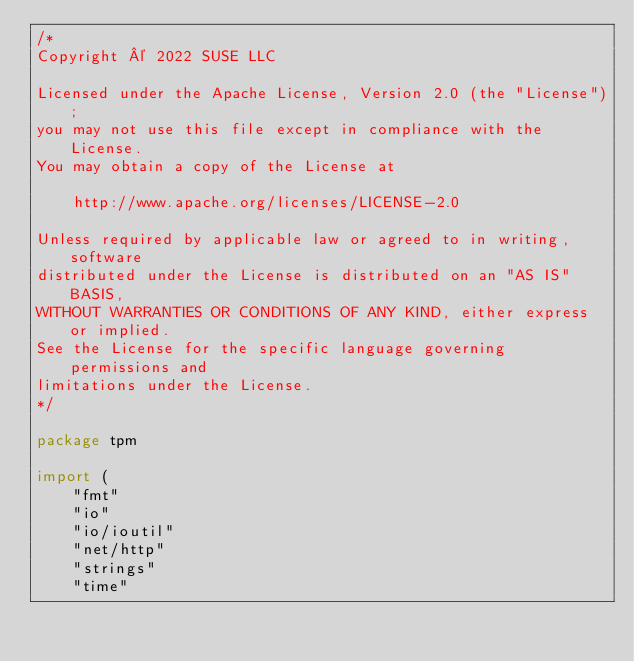<code> <loc_0><loc_0><loc_500><loc_500><_Go_>/*
Copyright © 2022 SUSE LLC

Licensed under the Apache License, Version 2.0 (the "License");
you may not use this file except in compliance with the License.
You may obtain a copy of the License at

    http://www.apache.org/licenses/LICENSE-2.0

Unless required by applicable law or agreed to in writing, software
distributed under the License is distributed on an "AS IS" BASIS,
WITHOUT WARRANTIES OR CONDITIONS OF ANY KIND, either express or implied.
See the License for the specific language governing permissions and
limitations under the License.
*/

package tpm

import (
	"fmt"
	"io"
	"io/ioutil"
	"net/http"
	"strings"
	"time"
</code> 